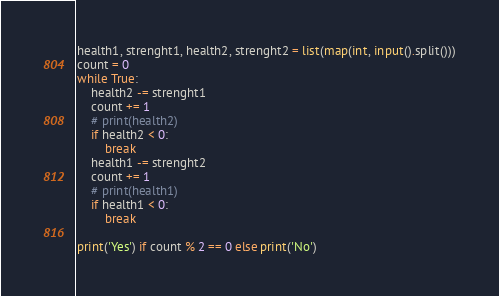<code> <loc_0><loc_0><loc_500><loc_500><_Python_>health1, strenght1, health2, strenght2 = list(map(int, input().split()))
count = 0
while True:
    health2 -= strenght1
    count += 1
    # print(health2)
    if health2 < 0:
        break
    health1 -= strenght2
    count += 1
    # print(health1)
    if health1 < 0:
        break

print('Yes') if count % 2 == 0 else print('No')
</code> 